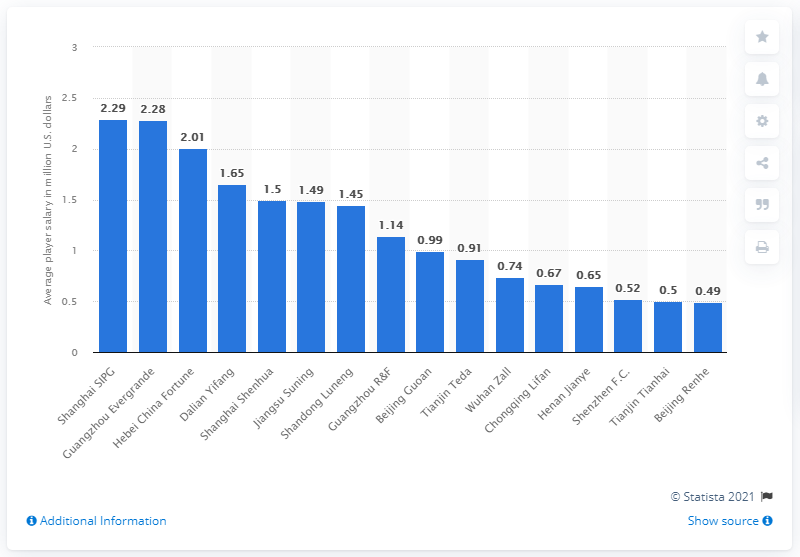Point out several critical features in this image. According to data from 2019, the average player salary in the Chinese Football Super League was 2.29 million yuan. 